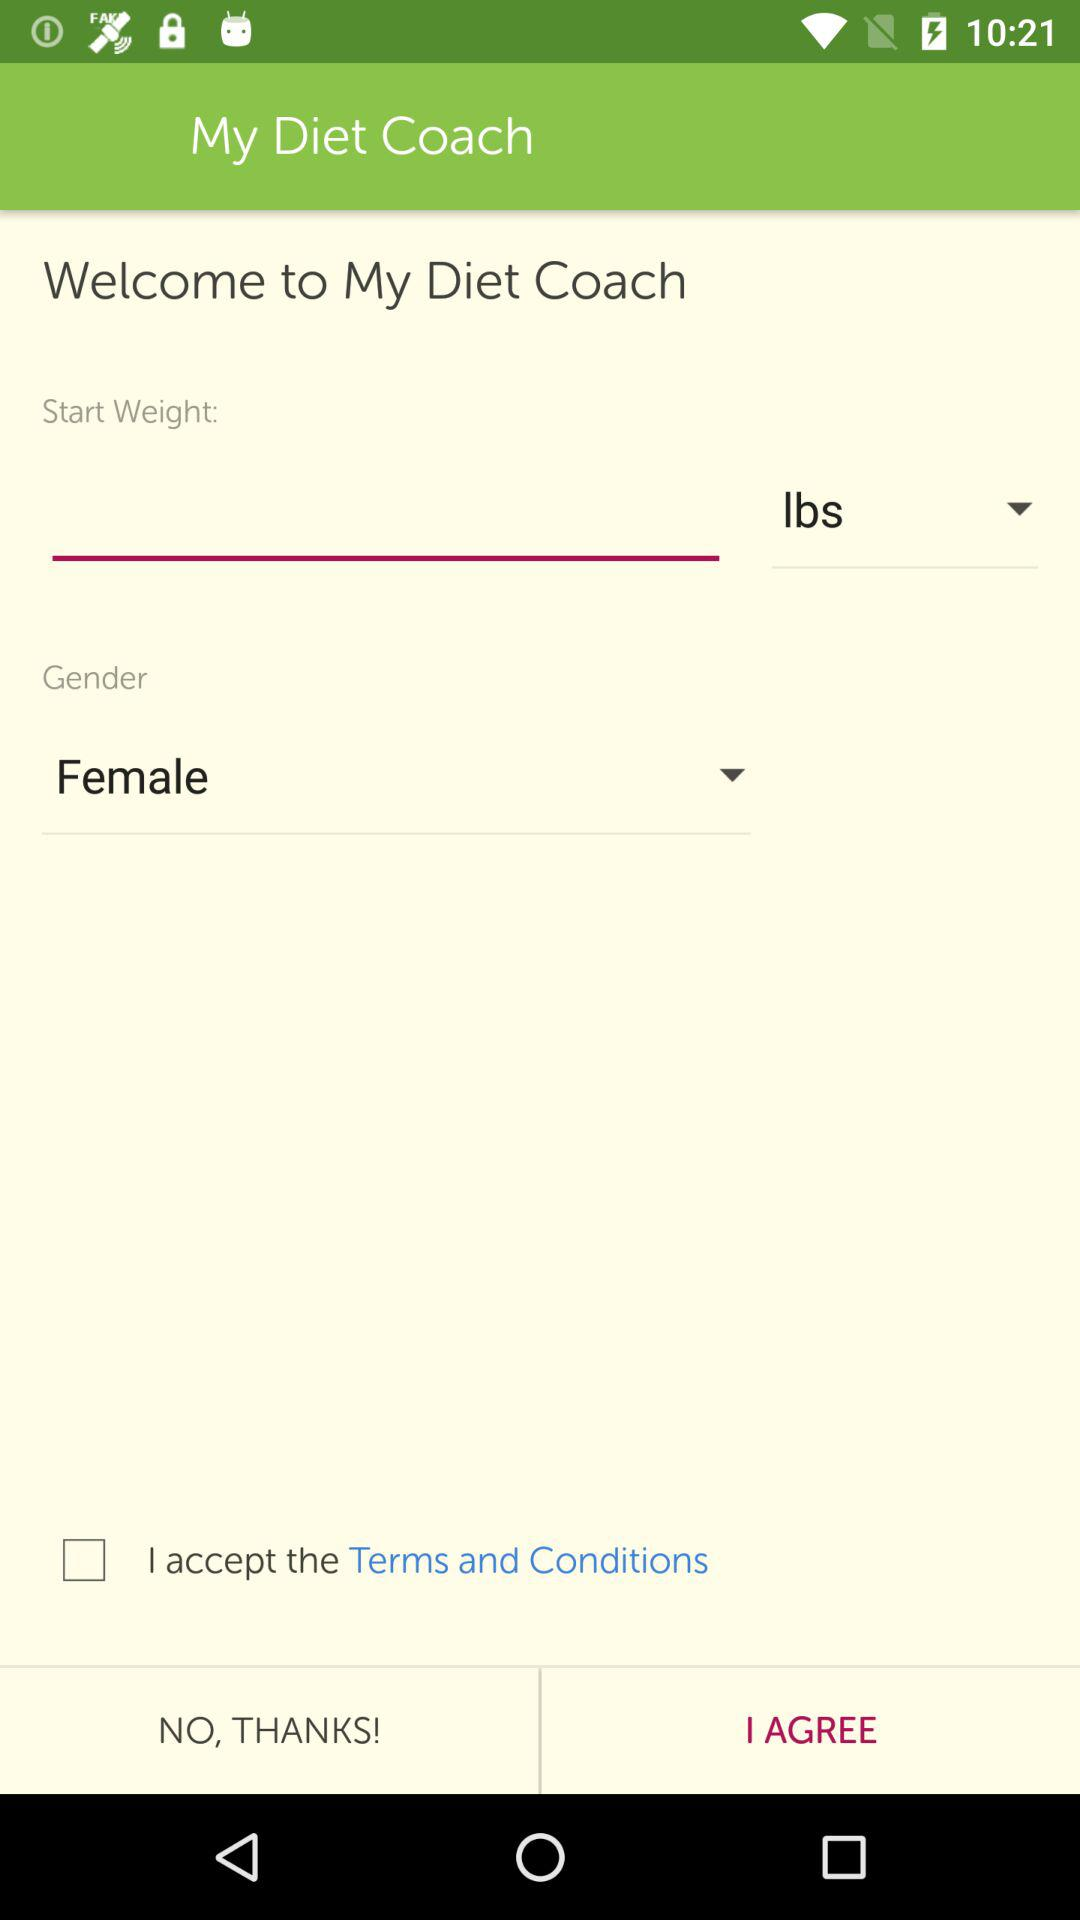What is the app's name? The app's name is "My Diet Coach". 